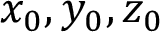Convert formula to latex. <formula><loc_0><loc_0><loc_500><loc_500>x _ { 0 } , y _ { 0 } , z _ { 0 }</formula> 